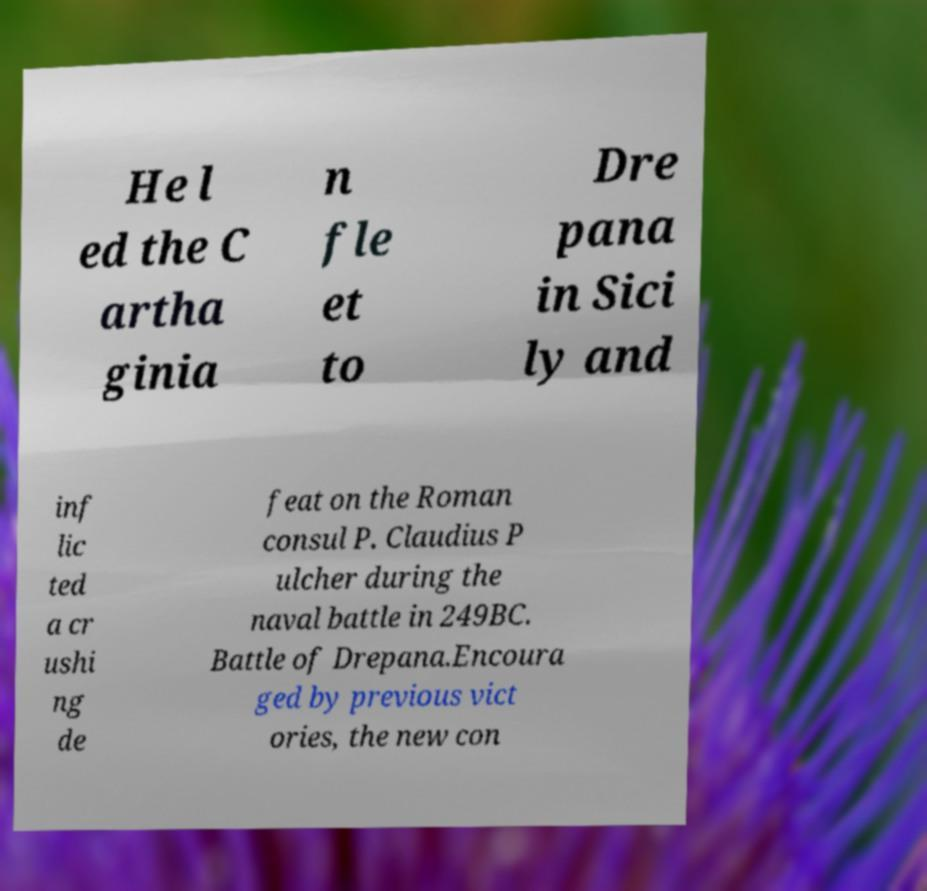Can you read and provide the text displayed in the image?This photo seems to have some interesting text. Can you extract and type it out for me? He l ed the C artha ginia n fle et to Dre pana in Sici ly and inf lic ted a cr ushi ng de feat on the Roman consul P. Claudius P ulcher during the naval battle in 249BC. Battle of Drepana.Encoura ged by previous vict ories, the new con 